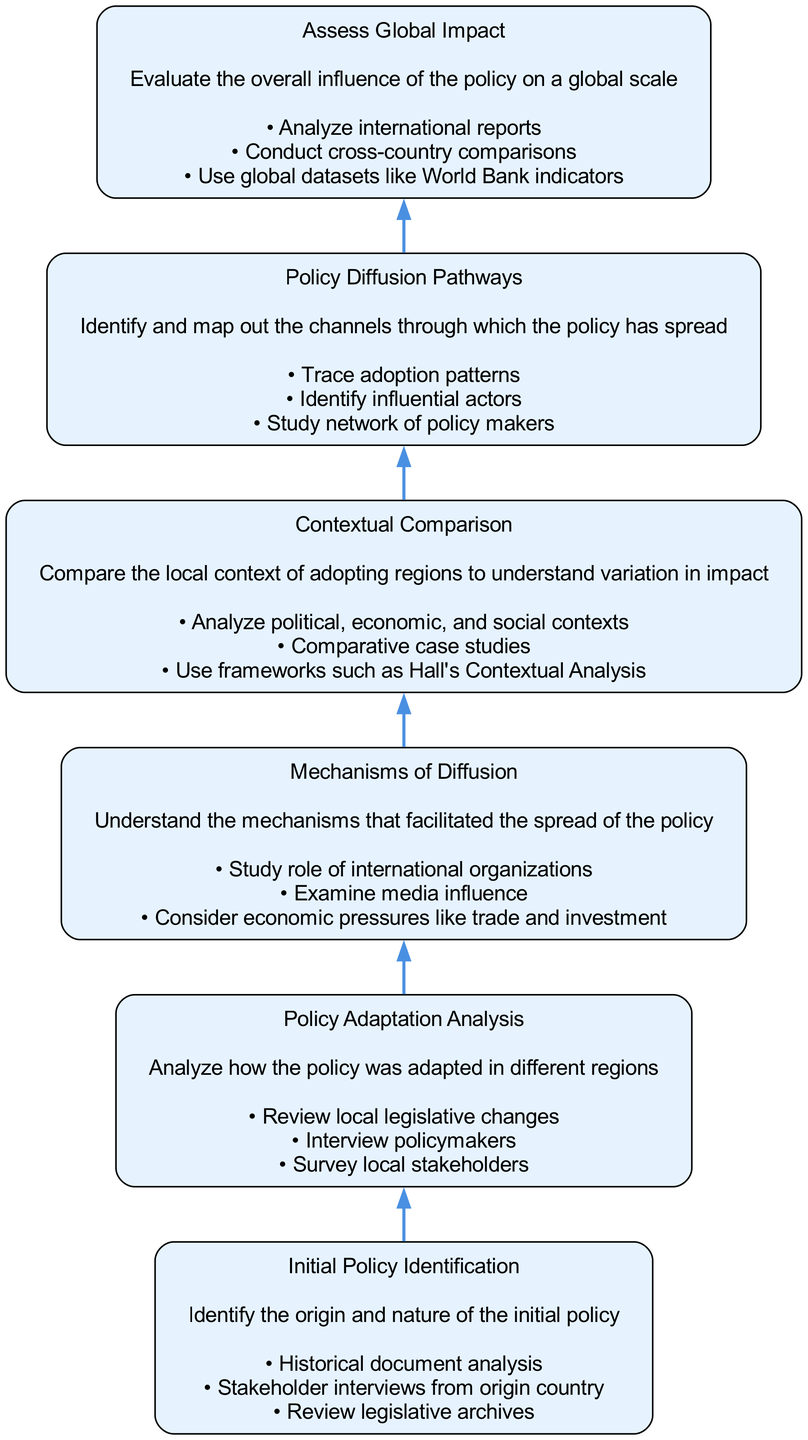What is the first node in the diagram? The first node in the diagram, which is located at the bottom, is "Initial Policy Identification". The placement at the base indicates it is the starting point of the process outlined in the flowchart.
Answer: Initial Policy Identification How many nodes are in the diagram? There are a total of six nodes in the diagram, each representing a distinct step in the policy diffusion study process. This is determined by counting each of the unique elements listed in the data.
Answer: 6 What is the last action described in the "Assess Global Impact" node? The last action in the "Assess Global Impact" node is "Use global datasets like World Bank indicators". This is identified by looking at the actions listed under this specific node, focusing on the sequence of actions described in the flowchart.
Answer: Use global datasets like World Bank indicators Which node describes the analysis of local contexts? The node that describes the analysis of local contexts is "Contextual Comparison". This is determined by reviewing the names and descriptions of the nodes to find the one that explicitly mentions comparing local contexts.
Answer: Contextual Comparison What are the actions listed under "Mechanisms of Diffusion"? The actions listed under "Mechanisms of Diffusion" are "Study role of international organizations," "Examine media influence," and "Consider economic pressures like trade and investment." This is obtained by reading the actions associated with that particular node in the flowchart.
Answer: Study role of international organizations; Examine media influence; Consider economic pressures like trade and investment Which two nodes are directly connected? The nodes "Initial Policy Identification" and "Policy Adaptation Analysis" are directly connected. This is determined by examining the flow direction in the diagram, where edges represent direct connections between successive nodes.
Answer: Initial Policy Identification and Policy Adaptation Analysis What represents the evaluation of the policy's influence? "Assess Global Impact" represents the evaluation of the policy's influence on a global scale. This is revealed by focusing on the title and description of that node, which explicitly states its purpose.
Answer: Assess Global Impact How does the process of analyzing the initial policy relate to policy adaptation? The process starts with "Initial Policy Identification" which leads to "Policy Adaptation Analysis." This shows the flow of information from understanding the origin and nature of the policy to analyzing how it was adapted in different regions, demonstrating a sequential relationship.
Answer: Initial Policy Identification leads to Policy Adaptation Analysis What describes the patterns of policy spread? "Policy Diffusion Pathways" describes the patterns of policy spread, as indicated by the node name and its description which focuses on identifying and mapping out the channels through which the policy has spread.
Answer: Policy Diffusion Pathways 